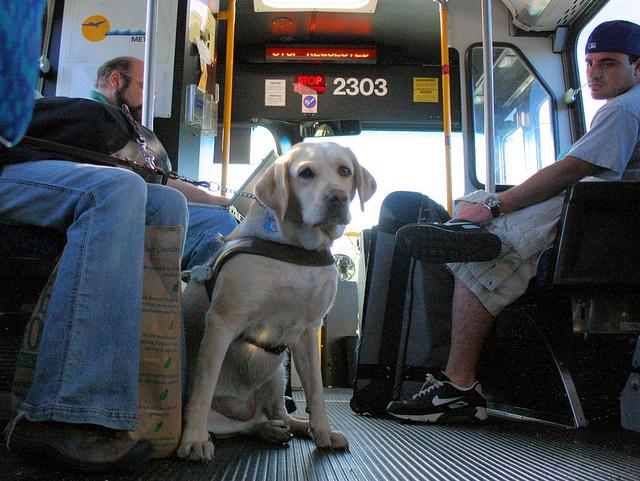Is this dog a service animal?
Be succinct. Yes. What is the white number?
Keep it brief. 2303. How many dogs are on the bus?
Quick response, please. 1. 